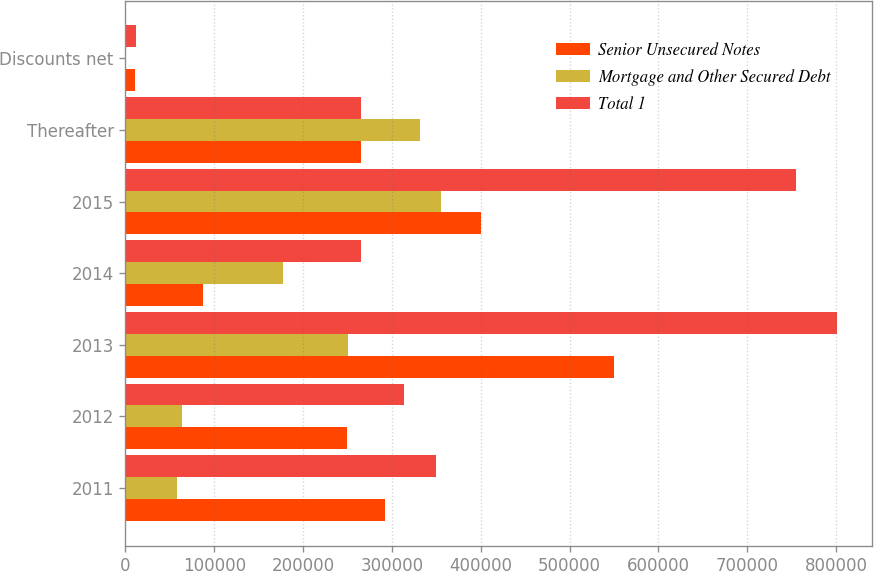<chart> <loc_0><loc_0><loc_500><loc_500><stacked_bar_chart><ecel><fcel>2011<fcel>2012<fcel>2013<fcel>2014<fcel>2015<fcel>Thereafter<fcel>Discounts net<nl><fcel>Senior Unsecured Notes<fcel>292265<fcel>250000<fcel>550000<fcel>87000<fcel>400000<fcel>264809<fcel>10886<nl><fcel>Mortgage and Other Secured Debt<fcel>57571<fcel>64103<fcel>250741<fcel>177809<fcel>355080<fcel>331748<fcel>1273<nl><fcel>Total 1<fcel>349836<fcel>314103<fcel>800741<fcel>264809<fcel>755080<fcel>264809<fcel>12159<nl></chart> 